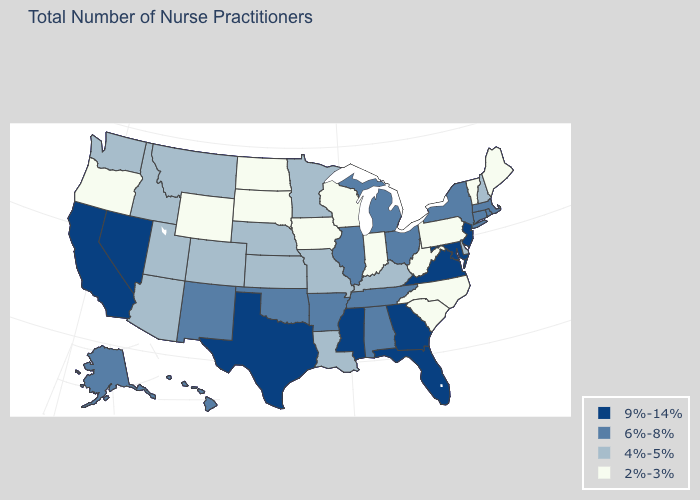Among the states that border West Virginia , which have the highest value?
Give a very brief answer. Maryland, Virginia. What is the value of Delaware?
Answer briefly. 4%-5%. What is the value of Kentucky?
Keep it brief. 4%-5%. What is the value of Oklahoma?
Quick response, please. 6%-8%. What is the value of Florida?
Short answer required. 9%-14%. Name the states that have a value in the range 9%-14%?
Concise answer only. California, Florida, Georgia, Maryland, Mississippi, Nevada, New Jersey, Texas, Virginia. What is the value of Tennessee?
Be succinct. 6%-8%. Which states have the highest value in the USA?
Short answer required. California, Florida, Georgia, Maryland, Mississippi, Nevada, New Jersey, Texas, Virginia. What is the lowest value in the USA?
Short answer required. 2%-3%. What is the value of Montana?
Keep it brief. 4%-5%. What is the value of Texas?
Give a very brief answer. 9%-14%. Does New Jersey have the highest value in the Northeast?
Give a very brief answer. Yes. What is the lowest value in the South?
Be succinct. 2%-3%. What is the value of Maine?
Keep it brief. 2%-3%. Does Delaware have a lower value than Rhode Island?
Concise answer only. Yes. 